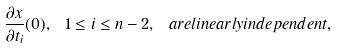Convert formula to latex. <formula><loc_0><loc_0><loc_500><loc_500>\frac { \partial x } { \partial t _ { i } } ( 0 ) , \ 1 \leq i \leq n - 2 , \ a r e l i n e a r l y i n d e p e n d e n t ,</formula> 